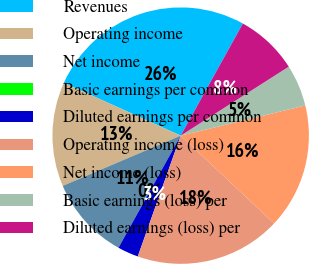Convert chart to OTSL. <chart><loc_0><loc_0><loc_500><loc_500><pie_chart><fcel>Revenues<fcel>Operating income<fcel>Net income<fcel>Basic earnings per common<fcel>Diluted earnings per common<fcel>Operating income (loss)<fcel>Net income (loss)<fcel>Basic earnings (loss) per<fcel>Diluted earnings (loss) per<nl><fcel>26.31%<fcel>13.16%<fcel>10.53%<fcel>0.0%<fcel>2.63%<fcel>18.42%<fcel>15.79%<fcel>5.26%<fcel>7.9%<nl></chart> 